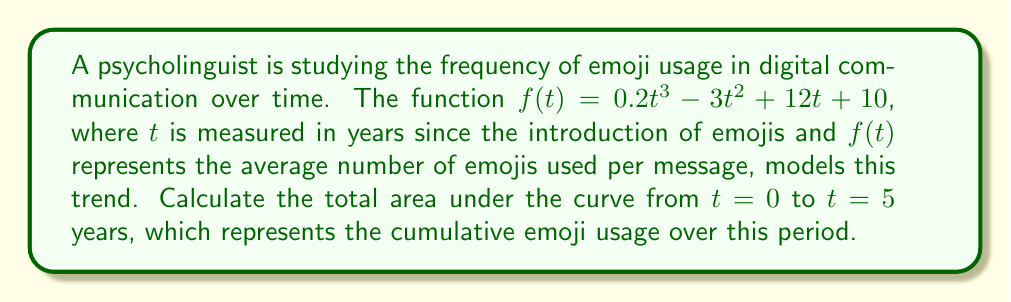Show me your answer to this math problem. To find the area under the curve, we need to integrate the function $f(t)$ from $t=0$ to $t=5$. Let's follow these steps:

1) The indefinite integral of $f(t)$ is:
   $$F(t) = \int f(t) dt = \int (0.2t^3 - 3t^2 + 12t + 10) dt$$
   $$F(t) = 0.05t^4 - t^3 + 6t^2 + 10t + C$$

2) Now, we'll use the definite integral to find the area:
   $$\text{Area} = \int_0^5 f(t) dt = F(5) - F(0)$$

3) Let's calculate $F(5)$:
   $$F(5) = 0.05(5^4) - 5^3 + 6(5^2) + 10(5) + C$$
   $$= 31.25 - 125 + 150 + 50 + C = 106.25 + C$$

4) Now $F(0)$:
   $$F(0) = 0.05(0^4) - 0^3 + 6(0^2) + 10(0) + C = C$$

5) Subtracting:
   $$\text{Area} = F(5) - F(0) = (106.25 + C) - C = 106.25$$

Therefore, the total area under the curve from $t=0$ to $t=5$ is 106.25.
Answer: 106.25 